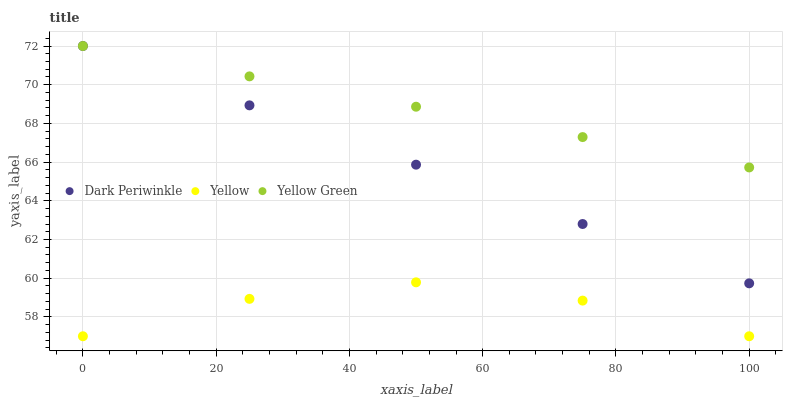Does Yellow have the minimum area under the curve?
Answer yes or no. Yes. Does Yellow Green have the maximum area under the curve?
Answer yes or no. Yes. Does Yellow Green have the minimum area under the curve?
Answer yes or no. No. Does Yellow have the maximum area under the curve?
Answer yes or no. No. Is Dark Periwinkle the smoothest?
Answer yes or no. Yes. Is Yellow the roughest?
Answer yes or no. Yes. Is Yellow Green the smoothest?
Answer yes or no. No. Is Yellow Green the roughest?
Answer yes or no. No. Does Yellow have the lowest value?
Answer yes or no. Yes. Does Yellow Green have the lowest value?
Answer yes or no. No. Does Yellow Green have the highest value?
Answer yes or no. Yes. Does Yellow have the highest value?
Answer yes or no. No. Is Yellow less than Dark Periwinkle?
Answer yes or no. Yes. Is Yellow Green greater than Yellow?
Answer yes or no. Yes. Does Yellow Green intersect Dark Periwinkle?
Answer yes or no. Yes. Is Yellow Green less than Dark Periwinkle?
Answer yes or no. No. Is Yellow Green greater than Dark Periwinkle?
Answer yes or no. No. Does Yellow intersect Dark Periwinkle?
Answer yes or no. No. 